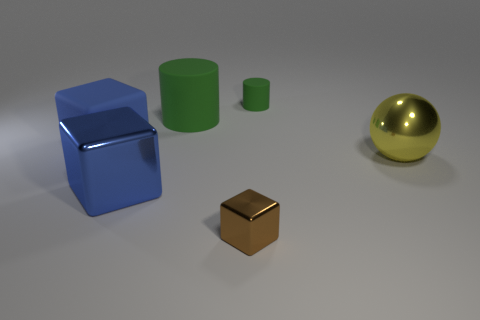Add 1 large yellow objects. How many objects exist? 7 Subtract all cylinders. How many objects are left? 4 Subtract all yellow metal blocks. Subtract all big matte cylinders. How many objects are left? 5 Add 6 yellow shiny objects. How many yellow shiny objects are left? 7 Add 1 big spheres. How many big spheres exist? 2 Subtract 0 purple blocks. How many objects are left? 6 